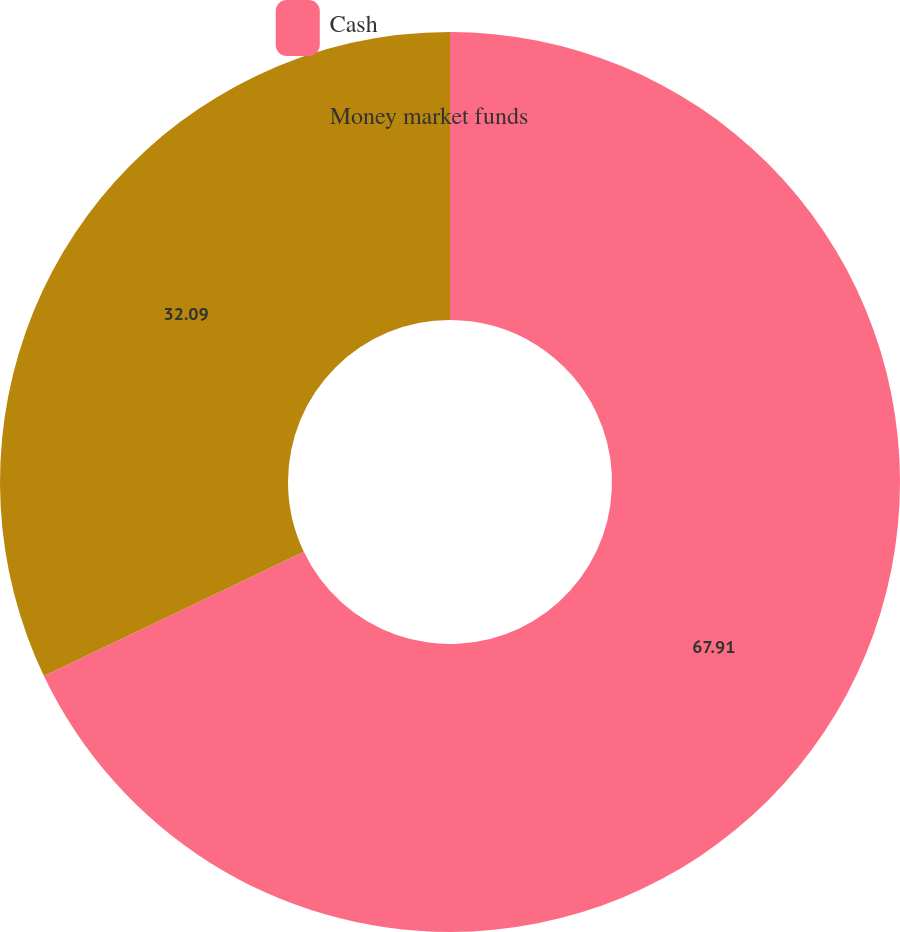<chart> <loc_0><loc_0><loc_500><loc_500><pie_chart><fcel>Cash<fcel>Money market funds<nl><fcel>67.91%<fcel>32.09%<nl></chart> 